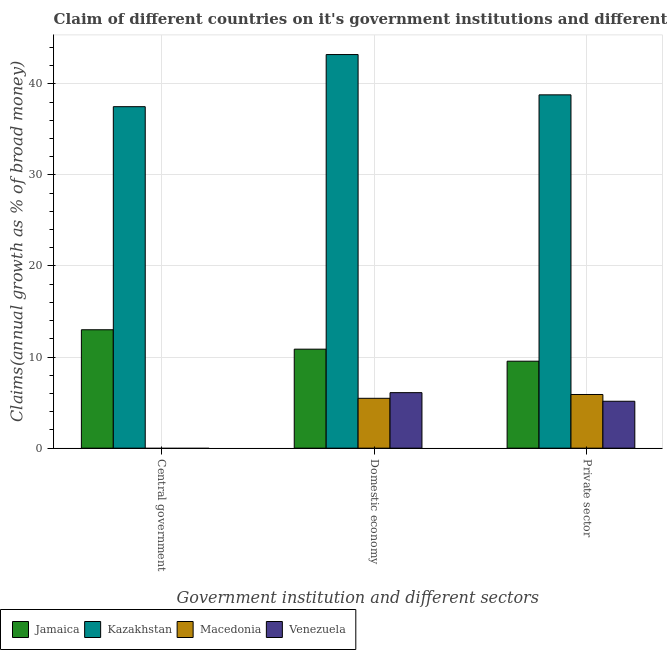Are the number of bars per tick equal to the number of legend labels?
Your answer should be compact. No. How many bars are there on the 2nd tick from the right?
Your response must be concise. 4. What is the label of the 1st group of bars from the left?
Your response must be concise. Central government. What is the percentage of claim on the private sector in Kazakhstan?
Offer a terse response. 38.79. Across all countries, what is the maximum percentage of claim on the private sector?
Give a very brief answer. 38.79. Across all countries, what is the minimum percentage of claim on the private sector?
Make the answer very short. 5.15. In which country was the percentage of claim on the domestic economy maximum?
Your answer should be compact. Kazakhstan. What is the total percentage of claim on the central government in the graph?
Your answer should be very brief. 50.49. What is the difference between the percentage of claim on the domestic economy in Venezuela and that in Kazakhstan?
Provide a short and direct response. -37.12. What is the difference between the percentage of claim on the domestic economy in Macedonia and the percentage of claim on the private sector in Kazakhstan?
Offer a terse response. -33.32. What is the average percentage of claim on the central government per country?
Make the answer very short. 12.62. What is the difference between the percentage of claim on the private sector and percentage of claim on the domestic economy in Kazakhstan?
Offer a terse response. -4.42. What is the ratio of the percentage of claim on the domestic economy in Macedonia to that in Venezuela?
Your response must be concise. 0.9. What is the difference between the highest and the second highest percentage of claim on the private sector?
Make the answer very short. 29.24. What is the difference between the highest and the lowest percentage of claim on the private sector?
Provide a short and direct response. 33.64. Is it the case that in every country, the sum of the percentage of claim on the central government and percentage of claim on the domestic economy is greater than the percentage of claim on the private sector?
Provide a short and direct response. No. How many bars are there?
Offer a terse response. 10. Does the graph contain grids?
Your answer should be very brief. Yes. Where does the legend appear in the graph?
Your response must be concise. Bottom left. How many legend labels are there?
Your answer should be compact. 4. What is the title of the graph?
Your answer should be compact. Claim of different countries on it's government institutions and different sectors. What is the label or title of the X-axis?
Make the answer very short. Government institution and different sectors. What is the label or title of the Y-axis?
Give a very brief answer. Claims(annual growth as % of broad money). What is the Claims(annual growth as % of broad money) in Jamaica in Central government?
Offer a very short reply. 13. What is the Claims(annual growth as % of broad money) in Kazakhstan in Central government?
Provide a succinct answer. 37.49. What is the Claims(annual growth as % of broad money) of Venezuela in Central government?
Your response must be concise. 0. What is the Claims(annual growth as % of broad money) in Jamaica in Domestic economy?
Give a very brief answer. 10.87. What is the Claims(annual growth as % of broad money) in Kazakhstan in Domestic economy?
Provide a short and direct response. 43.21. What is the Claims(annual growth as % of broad money) of Macedonia in Domestic economy?
Your answer should be compact. 5.47. What is the Claims(annual growth as % of broad money) in Venezuela in Domestic economy?
Make the answer very short. 6.09. What is the Claims(annual growth as % of broad money) of Jamaica in Private sector?
Ensure brevity in your answer.  9.55. What is the Claims(annual growth as % of broad money) in Kazakhstan in Private sector?
Your answer should be very brief. 38.79. What is the Claims(annual growth as % of broad money) of Macedonia in Private sector?
Your response must be concise. 5.89. What is the Claims(annual growth as % of broad money) in Venezuela in Private sector?
Ensure brevity in your answer.  5.15. Across all Government institution and different sectors, what is the maximum Claims(annual growth as % of broad money) in Jamaica?
Provide a succinct answer. 13. Across all Government institution and different sectors, what is the maximum Claims(annual growth as % of broad money) in Kazakhstan?
Give a very brief answer. 43.21. Across all Government institution and different sectors, what is the maximum Claims(annual growth as % of broad money) of Macedonia?
Offer a terse response. 5.89. Across all Government institution and different sectors, what is the maximum Claims(annual growth as % of broad money) of Venezuela?
Your answer should be very brief. 6.09. Across all Government institution and different sectors, what is the minimum Claims(annual growth as % of broad money) in Jamaica?
Provide a short and direct response. 9.55. Across all Government institution and different sectors, what is the minimum Claims(annual growth as % of broad money) in Kazakhstan?
Your answer should be very brief. 37.49. Across all Government institution and different sectors, what is the minimum Claims(annual growth as % of broad money) of Macedonia?
Your answer should be compact. 0. Across all Government institution and different sectors, what is the minimum Claims(annual growth as % of broad money) in Venezuela?
Keep it short and to the point. 0. What is the total Claims(annual growth as % of broad money) of Jamaica in the graph?
Keep it short and to the point. 33.42. What is the total Claims(annual growth as % of broad money) in Kazakhstan in the graph?
Your response must be concise. 119.49. What is the total Claims(annual growth as % of broad money) in Macedonia in the graph?
Provide a succinct answer. 11.37. What is the total Claims(annual growth as % of broad money) in Venezuela in the graph?
Give a very brief answer. 11.24. What is the difference between the Claims(annual growth as % of broad money) in Jamaica in Central government and that in Domestic economy?
Ensure brevity in your answer.  2.13. What is the difference between the Claims(annual growth as % of broad money) in Kazakhstan in Central government and that in Domestic economy?
Provide a succinct answer. -5.72. What is the difference between the Claims(annual growth as % of broad money) of Jamaica in Central government and that in Private sector?
Your answer should be compact. 3.45. What is the difference between the Claims(annual growth as % of broad money) of Kazakhstan in Central government and that in Private sector?
Ensure brevity in your answer.  -1.3. What is the difference between the Claims(annual growth as % of broad money) in Jamaica in Domestic economy and that in Private sector?
Provide a succinct answer. 1.32. What is the difference between the Claims(annual growth as % of broad money) in Kazakhstan in Domestic economy and that in Private sector?
Your answer should be compact. 4.42. What is the difference between the Claims(annual growth as % of broad money) in Macedonia in Domestic economy and that in Private sector?
Offer a terse response. -0.42. What is the difference between the Claims(annual growth as % of broad money) in Jamaica in Central government and the Claims(annual growth as % of broad money) in Kazakhstan in Domestic economy?
Provide a succinct answer. -30.21. What is the difference between the Claims(annual growth as % of broad money) of Jamaica in Central government and the Claims(annual growth as % of broad money) of Macedonia in Domestic economy?
Provide a succinct answer. 7.53. What is the difference between the Claims(annual growth as % of broad money) of Jamaica in Central government and the Claims(annual growth as % of broad money) of Venezuela in Domestic economy?
Your response must be concise. 6.91. What is the difference between the Claims(annual growth as % of broad money) in Kazakhstan in Central government and the Claims(annual growth as % of broad money) in Macedonia in Domestic economy?
Ensure brevity in your answer.  32.02. What is the difference between the Claims(annual growth as % of broad money) in Kazakhstan in Central government and the Claims(annual growth as % of broad money) in Venezuela in Domestic economy?
Keep it short and to the point. 31.4. What is the difference between the Claims(annual growth as % of broad money) in Jamaica in Central government and the Claims(annual growth as % of broad money) in Kazakhstan in Private sector?
Provide a succinct answer. -25.79. What is the difference between the Claims(annual growth as % of broad money) of Jamaica in Central government and the Claims(annual growth as % of broad money) of Macedonia in Private sector?
Your answer should be compact. 7.11. What is the difference between the Claims(annual growth as % of broad money) in Jamaica in Central government and the Claims(annual growth as % of broad money) in Venezuela in Private sector?
Keep it short and to the point. 7.85. What is the difference between the Claims(annual growth as % of broad money) of Kazakhstan in Central government and the Claims(annual growth as % of broad money) of Macedonia in Private sector?
Your response must be concise. 31.6. What is the difference between the Claims(annual growth as % of broad money) of Kazakhstan in Central government and the Claims(annual growth as % of broad money) of Venezuela in Private sector?
Offer a terse response. 32.34. What is the difference between the Claims(annual growth as % of broad money) of Jamaica in Domestic economy and the Claims(annual growth as % of broad money) of Kazakhstan in Private sector?
Make the answer very short. -27.92. What is the difference between the Claims(annual growth as % of broad money) of Jamaica in Domestic economy and the Claims(annual growth as % of broad money) of Macedonia in Private sector?
Provide a short and direct response. 4.98. What is the difference between the Claims(annual growth as % of broad money) of Jamaica in Domestic economy and the Claims(annual growth as % of broad money) of Venezuela in Private sector?
Provide a succinct answer. 5.72. What is the difference between the Claims(annual growth as % of broad money) of Kazakhstan in Domestic economy and the Claims(annual growth as % of broad money) of Macedonia in Private sector?
Your response must be concise. 37.32. What is the difference between the Claims(annual growth as % of broad money) in Kazakhstan in Domestic economy and the Claims(annual growth as % of broad money) in Venezuela in Private sector?
Keep it short and to the point. 38.06. What is the difference between the Claims(annual growth as % of broad money) of Macedonia in Domestic economy and the Claims(annual growth as % of broad money) of Venezuela in Private sector?
Ensure brevity in your answer.  0.32. What is the average Claims(annual growth as % of broad money) in Jamaica per Government institution and different sectors?
Your answer should be compact. 11.14. What is the average Claims(annual growth as % of broad money) of Kazakhstan per Government institution and different sectors?
Your answer should be very brief. 39.83. What is the average Claims(annual growth as % of broad money) in Macedonia per Government institution and different sectors?
Offer a very short reply. 3.79. What is the average Claims(annual growth as % of broad money) in Venezuela per Government institution and different sectors?
Your answer should be very brief. 3.75. What is the difference between the Claims(annual growth as % of broad money) of Jamaica and Claims(annual growth as % of broad money) of Kazakhstan in Central government?
Keep it short and to the point. -24.49. What is the difference between the Claims(annual growth as % of broad money) of Jamaica and Claims(annual growth as % of broad money) of Kazakhstan in Domestic economy?
Offer a very short reply. -32.35. What is the difference between the Claims(annual growth as % of broad money) of Jamaica and Claims(annual growth as % of broad money) of Macedonia in Domestic economy?
Your answer should be very brief. 5.39. What is the difference between the Claims(annual growth as % of broad money) in Jamaica and Claims(annual growth as % of broad money) in Venezuela in Domestic economy?
Provide a short and direct response. 4.77. What is the difference between the Claims(annual growth as % of broad money) in Kazakhstan and Claims(annual growth as % of broad money) in Macedonia in Domestic economy?
Keep it short and to the point. 37.74. What is the difference between the Claims(annual growth as % of broad money) of Kazakhstan and Claims(annual growth as % of broad money) of Venezuela in Domestic economy?
Provide a succinct answer. 37.12. What is the difference between the Claims(annual growth as % of broad money) of Macedonia and Claims(annual growth as % of broad money) of Venezuela in Domestic economy?
Keep it short and to the point. -0.62. What is the difference between the Claims(annual growth as % of broad money) of Jamaica and Claims(annual growth as % of broad money) of Kazakhstan in Private sector?
Ensure brevity in your answer.  -29.24. What is the difference between the Claims(annual growth as % of broad money) in Jamaica and Claims(annual growth as % of broad money) in Macedonia in Private sector?
Keep it short and to the point. 3.66. What is the difference between the Claims(annual growth as % of broad money) of Jamaica and Claims(annual growth as % of broad money) of Venezuela in Private sector?
Your answer should be compact. 4.4. What is the difference between the Claims(annual growth as % of broad money) in Kazakhstan and Claims(annual growth as % of broad money) in Macedonia in Private sector?
Provide a short and direct response. 32.9. What is the difference between the Claims(annual growth as % of broad money) of Kazakhstan and Claims(annual growth as % of broad money) of Venezuela in Private sector?
Give a very brief answer. 33.64. What is the difference between the Claims(annual growth as % of broad money) of Macedonia and Claims(annual growth as % of broad money) of Venezuela in Private sector?
Your response must be concise. 0.74. What is the ratio of the Claims(annual growth as % of broad money) in Jamaica in Central government to that in Domestic economy?
Give a very brief answer. 1.2. What is the ratio of the Claims(annual growth as % of broad money) of Kazakhstan in Central government to that in Domestic economy?
Keep it short and to the point. 0.87. What is the ratio of the Claims(annual growth as % of broad money) in Jamaica in Central government to that in Private sector?
Provide a succinct answer. 1.36. What is the ratio of the Claims(annual growth as % of broad money) in Kazakhstan in Central government to that in Private sector?
Your answer should be very brief. 0.97. What is the ratio of the Claims(annual growth as % of broad money) of Jamaica in Domestic economy to that in Private sector?
Your response must be concise. 1.14. What is the ratio of the Claims(annual growth as % of broad money) in Kazakhstan in Domestic economy to that in Private sector?
Your answer should be very brief. 1.11. What is the ratio of the Claims(annual growth as % of broad money) of Macedonia in Domestic economy to that in Private sector?
Your answer should be very brief. 0.93. What is the ratio of the Claims(annual growth as % of broad money) of Venezuela in Domestic economy to that in Private sector?
Offer a terse response. 1.18. What is the difference between the highest and the second highest Claims(annual growth as % of broad money) in Jamaica?
Make the answer very short. 2.13. What is the difference between the highest and the second highest Claims(annual growth as % of broad money) of Kazakhstan?
Your answer should be very brief. 4.42. What is the difference between the highest and the lowest Claims(annual growth as % of broad money) of Jamaica?
Your response must be concise. 3.45. What is the difference between the highest and the lowest Claims(annual growth as % of broad money) of Kazakhstan?
Your answer should be compact. 5.72. What is the difference between the highest and the lowest Claims(annual growth as % of broad money) of Macedonia?
Ensure brevity in your answer.  5.89. What is the difference between the highest and the lowest Claims(annual growth as % of broad money) in Venezuela?
Offer a terse response. 6.09. 